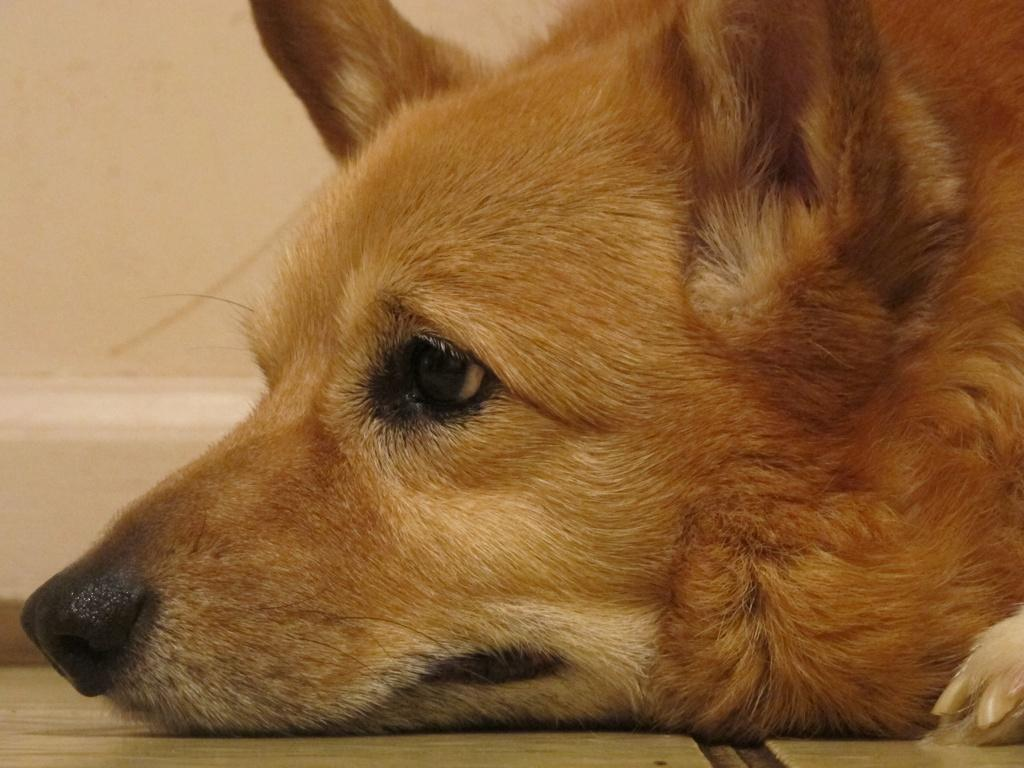What type of animal is in the image? There is a dog in the image. What is the dog doing in the image? The dog is lying on the floor. What can be seen behind the dog in the image? There is a wall visible behind the dog. What type of education can be seen in the image? There is no reference to education in the image; it features a dog lying on the floor with a wall visible behind it. 